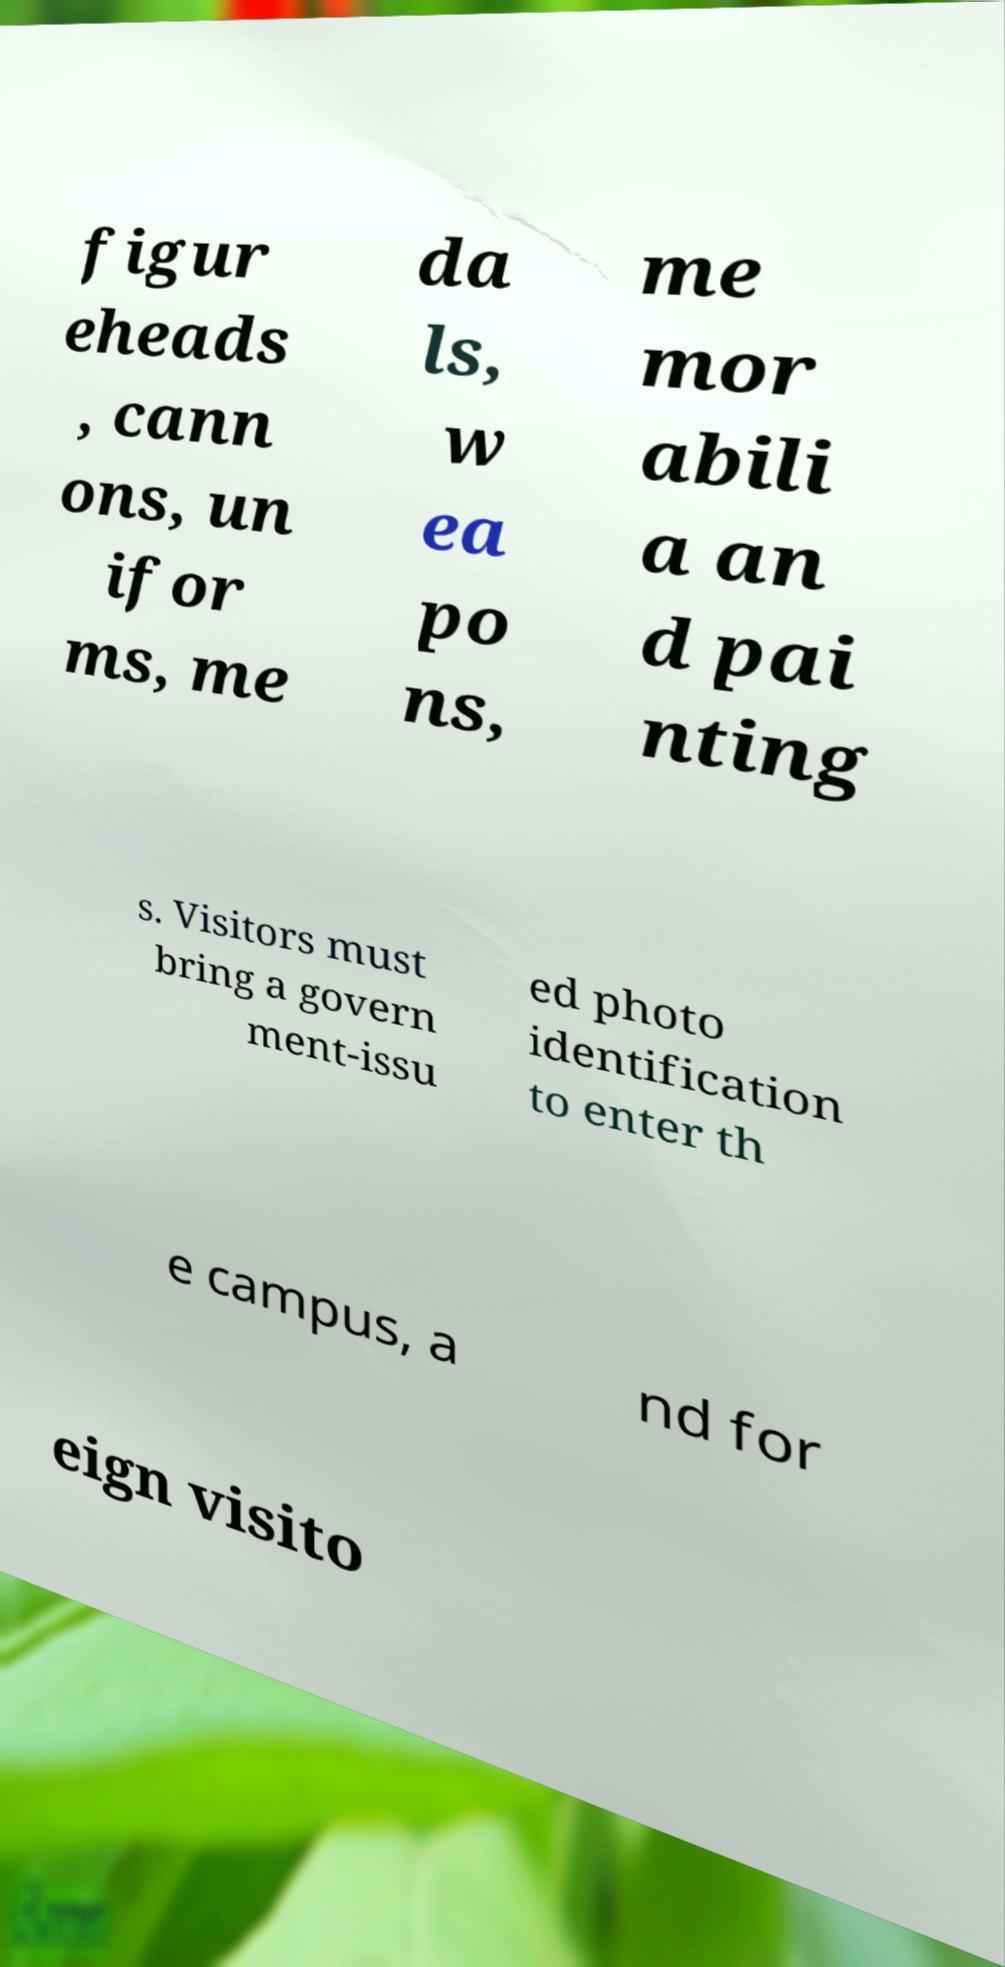Can you read and provide the text displayed in the image?This photo seems to have some interesting text. Can you extract and type it out for me? figur eheads , cann ons, un ifor ms, me da ls, w ea po ns, me mor abili a an d pai nting s. Visitors must bring a govern ment-issu ed photo identification to enter th e campus, a nd for eign visito 